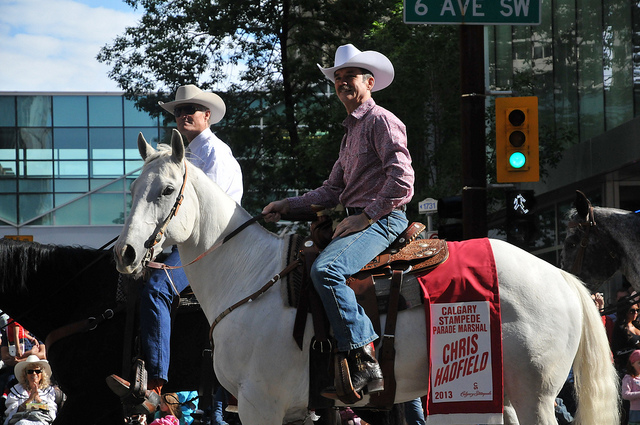Please extract the text content from this image. STAMPEDE CHRIS HADFIELD 6 2013 SW AVE 